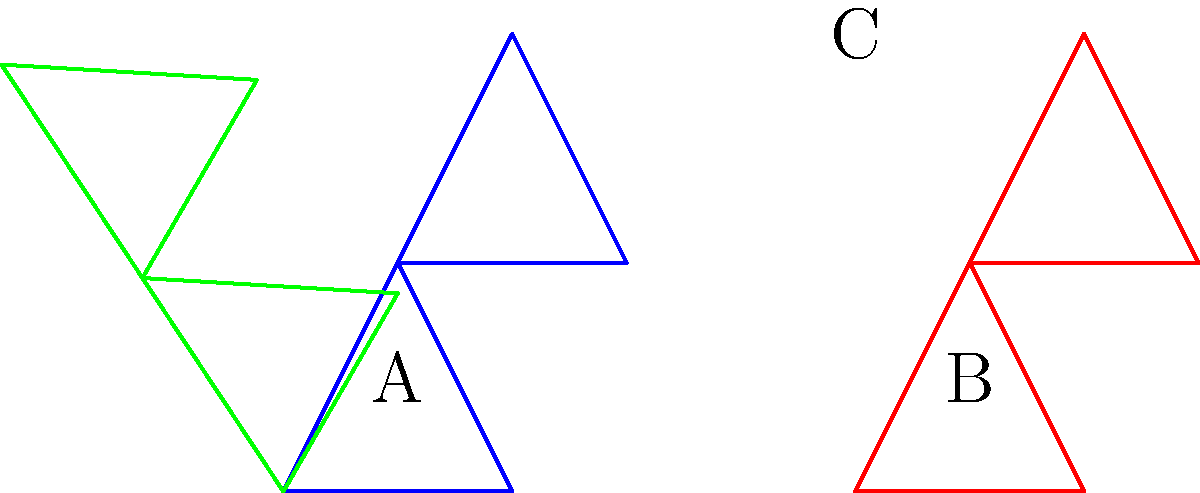As a marine biology student studying coral reef structures, which of the coral formations (A, B, or C) is a rotated version of formation A? To solve this problem, we need to mentally rotate each coral formation and compare it to formation A. Let's break it down step-by-step:

1. First, observe the shape of formation A. It consists of two triangles: one pointing upwards and another on top of it, also pointing upwards.

2. Now, let's look at formation B:
   - It has a similar structure to A with two triangles.
   - However, the orientation and proportions are exactly the same as A.
   - This means B is not a rotated version of A, but rather a translated (moved) version.

3. Finally, let's examine formation C:
   - It also consists of two triangles.
   - The overall shape looks similar to A, but it's oriented differently.
   - If we mentally rotate C clockwise by about 60 degrees, it would match the shape and orientation of A.

4. Therefore, formation C is the rotated version of formation A.

This exercise tests your ability to mentally manipulate 3D structures, which is crucial in understanding coral reef formations and their spatial relationships in marine ecosystems.
Answer: C 